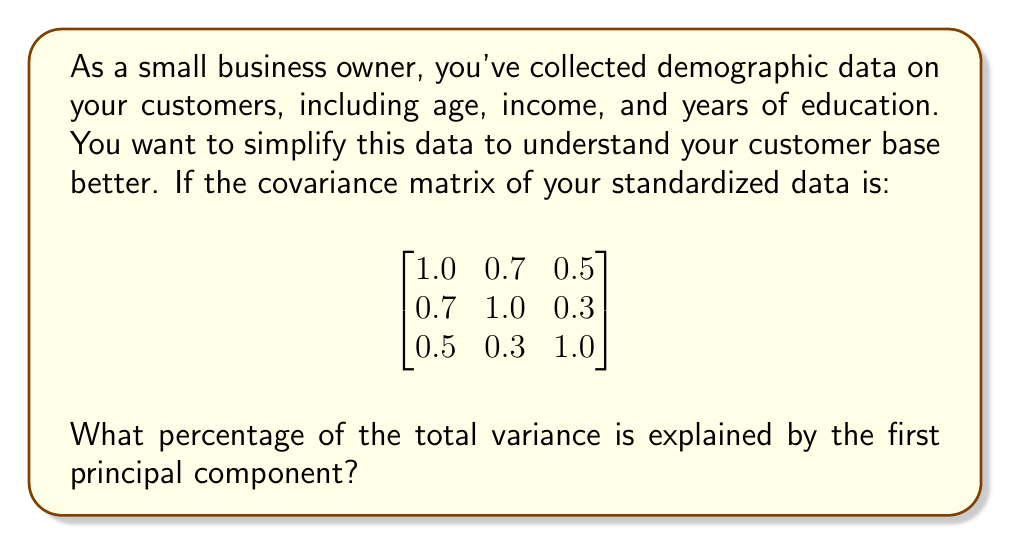Teach me how to tackle this problem. To find the percentage of variance explained by the first principal component, we need to follow these steps:

1. Find the eigenvalues of the covariance matrix.
2. The largest eigenvalue corresponds to the first principal component.
3. Calculate the total variance (sum of all eigenvalues).
4. Divide the largest eigenvalue by the total variance and multiply by 100.

Step 1: Find the eigenvalues
To find the eigenvalues, we need to solve the characteristic equation:
$$\det(A - \lambda I) = 0$$

Where $A$ is our covariance matrix and $I$ is the 3x3 identity matrix.

$$\det\begin{pmatrix}
1-\lambda & 0.7 & 0.5 \\
0.7 & 1-\lambda & 0.3 \\
0.5 & 0.3 & 1-\lambda
\end{pmatrix} = 0$$

Expanding this determinant gives us the characteristic polynomial:
$$-\lambda^3 + 3\lambda^2 - 2.27\lambda + 0.468 = 0$$

Solving this equation (using a calculator or computer algebra system) gives us the eigenvalues:
$$\lambda_1 \approx 2.173, \lambda_2 \approx 0.616, \lambda_3 \approx 0.211$$

Step 2: The largest eigenvalue (2.173) corresponds to the first principal component.

Step 3: Calculate the total variance
Total variance = sum of all eigenvalues = 2.173 + 0.616 + 0.211 = 3

Step 4: Calculate the percentage of variance explained
Percentage = (Largest eigenvalue / Total variance) * 100
           = (2.173 / 3) * 100
           ≈ 72.43%

Therefore, the first principal component explains approximately 72.43% of the total variance in your customer demographic data.
Answer: 72.43% 